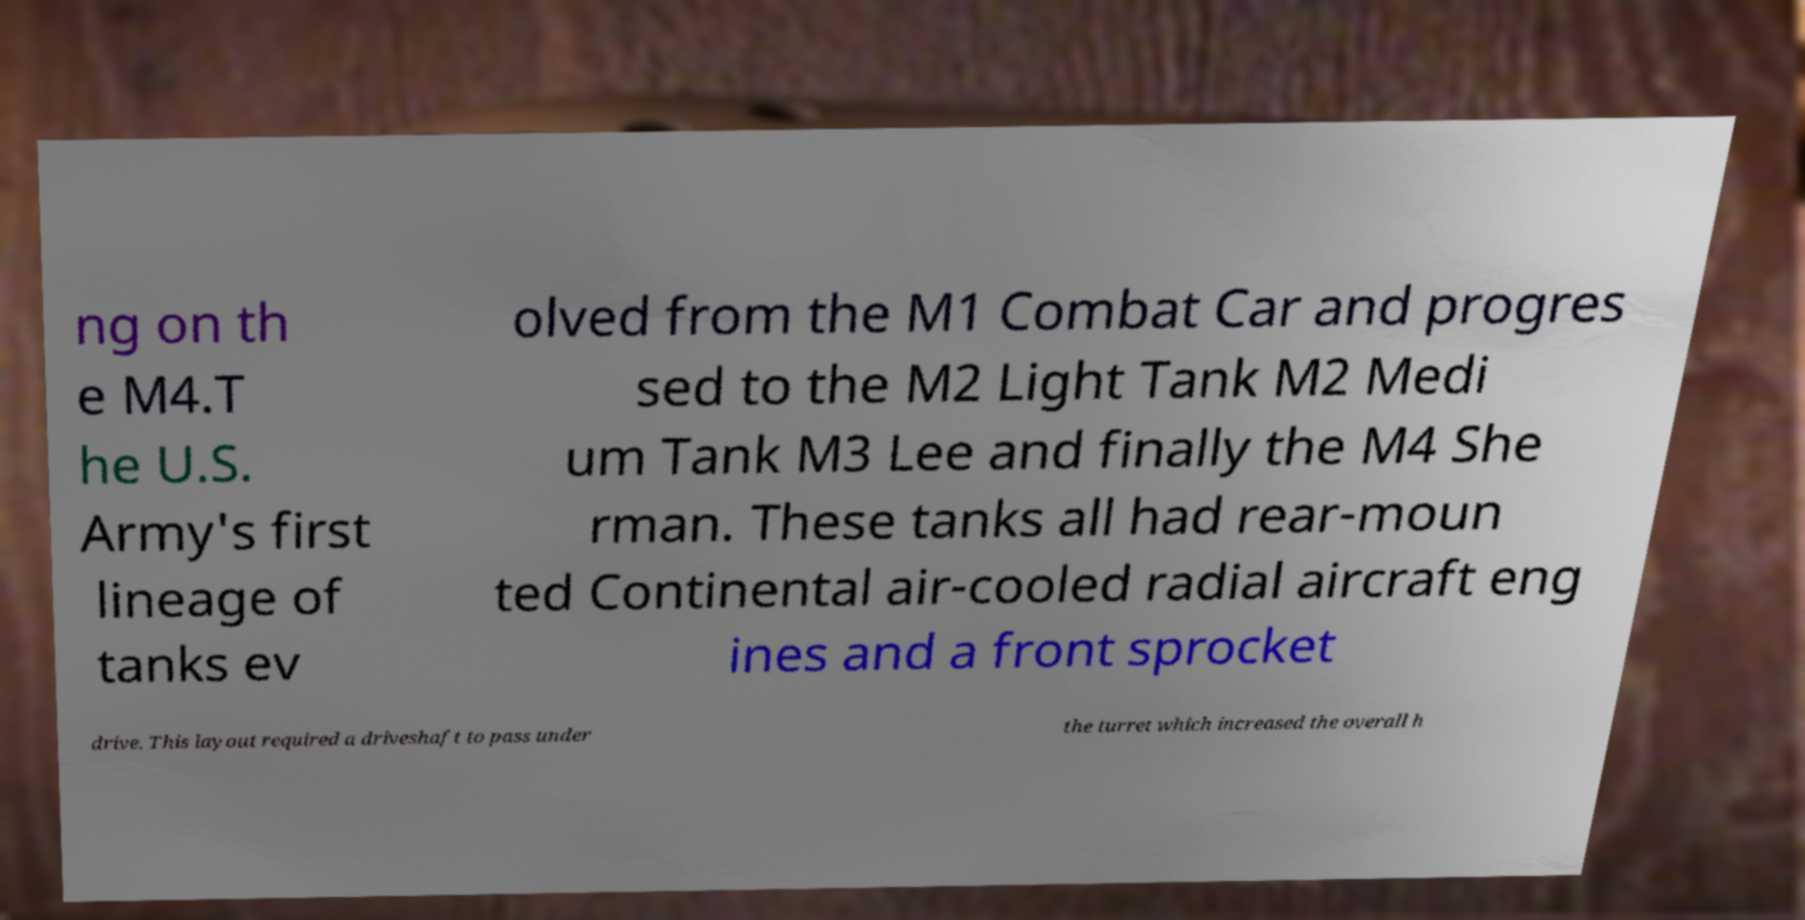There's text embedded in this image that I need extracted. Can you transcribe it verbatim? ng on th e M4.T he U.S. Army's first lineage of tanks ev olved from the M1 Combat Car and progres sed to the M2 Light Tank M2 Medi um Tank M3 Lee and finally the M4 She rman. These tanks all had rear-moun ted Continental air-cooled radial aircraft eng ines and a front sprocket drive. This layout required a driveshaft to pass under the turret which increased the overall h 